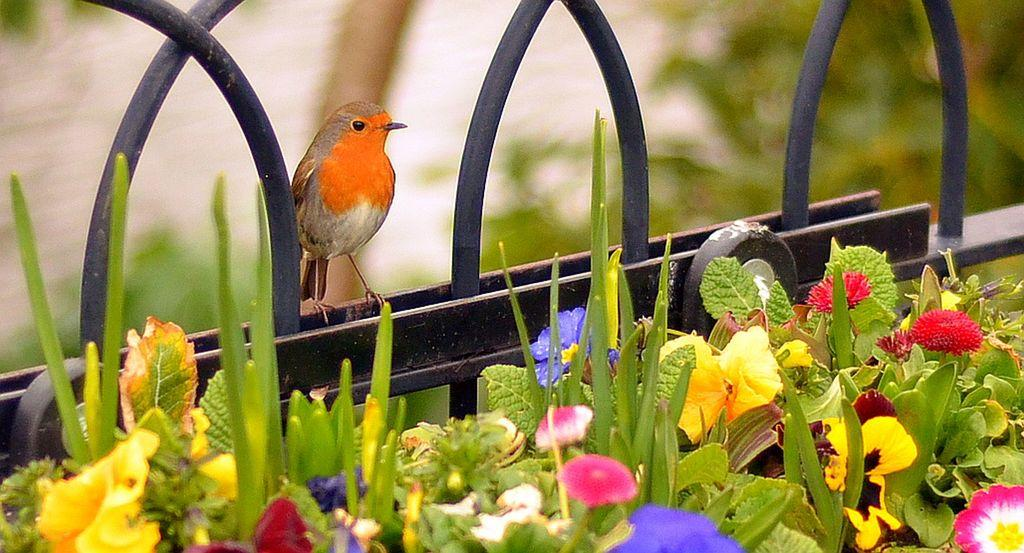What type of animal is present in the image? There is a bird in the image. What is the bird standing on? The bird is standing on an iron grill. What type of vegetation can be seen in the image? There are flowers and plants in the image. What letter is the bird holding in its beak in the image? There is no letter present in the image; the bird is standing on an iron grill and surrounded by flowers and plants. 